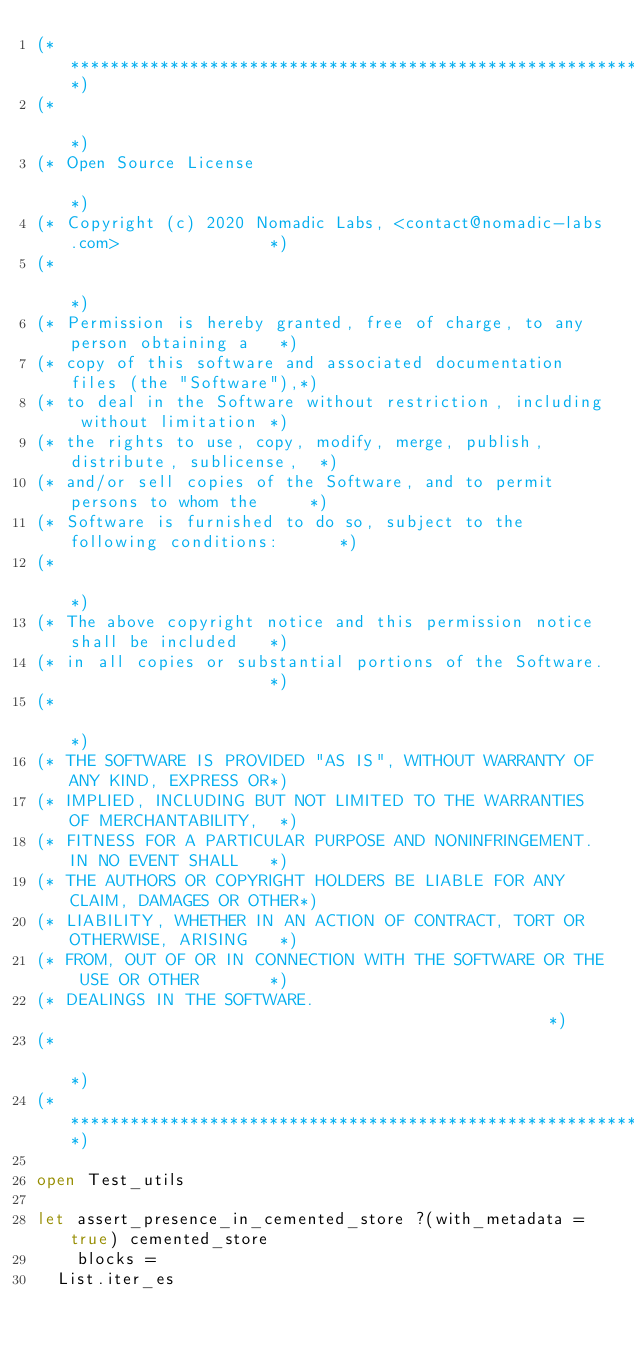Convert code to text. <code><loc_0><loc_0><loc_500><loc_500><_OCaml_>(*****************************************************************************)
(*                                                                           *)
(* Open Source License                                                       *)
(* Copyright (c) 2020 Nomadic Labs, <contact@nomadic-labs.com>               *)
(*                                                                           *)
(* Permission is hereby granted, free of charge, to any person obtaining a   *)
(* copy of this software and associated documentation files (the "Software"),*)
(* to deal in the Software without restriction, including without limitation *)
(* the rights to use, copy, modify, merge, publish, distribute, sublicense,  *)
(* and/or sell copies of the Software, and to permit persons to whom the     *)
(* Software is furnished to do so, subject to the following conditions:      *)
(*                                                                           *)
(* The above copyright notice and this permission notice shall be included   *)
(* in all copies or substantial portions of the Software.                    *)
(*                                                                           *)
(* THE SOFTWARE IS PROVIDED "AS IS", WITHOUT WARRANTY OF ANY KIND, EXPRESS OR*)
(* IMPLIED, INCLUDING BUT NOT LIMITED TO THE WARRANTIES OF MERCHANTABILITY,  *)
(* FITNESS FOR A PARTICULAR PURPOSE AND NONINFRINGEMENT. IN NO EVENT SHALL   *)
(* THE AUTHORS OR COPYRIGHT HOLDERS BE LIABLE FOR ANY CLAIM, DAMAGES OR OTHER*)
(* LIABILITY, WHETHER IN AN ACTION OF CONTRACT, TORT OR OTHERWISE, ARISING   *)
(* FROM, OUT OF OR IN CONNECTION WITH THE SOFTWARE OR THE USE OR OTHER       *)
(* DEALINGS IN THE SOFTWARE.                                                 *)
(*                                                                           *)
(*****************************************************************************)

open Test_utils

let assert_presence_in_cemented_store ?(with_metadata = true) cemented_store
    blocks =
  List.iter_es</code> 